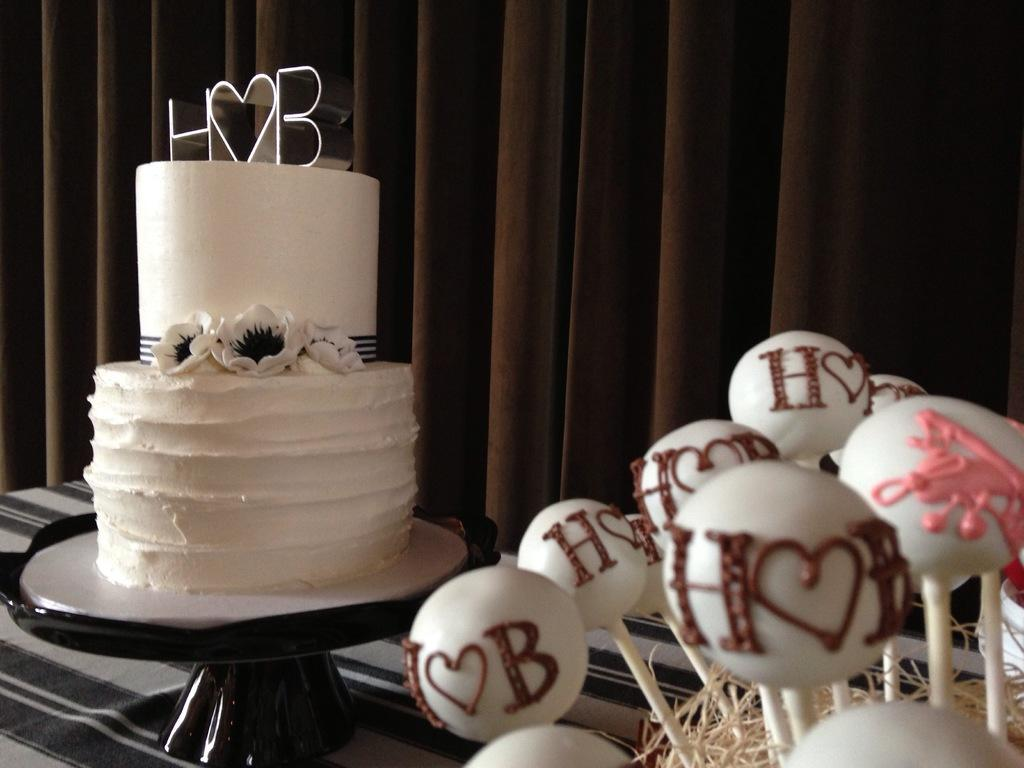What is the main subject of the image? There is a cake in the image. What is the cake placed on? The cake is placed on an object. What is the object on? The object is on a cloth. What can be seen on the right side of the image? There are food items on the right side of the image. What type of window treatment is visible in the image? There are curtains visible in the image. What type of mine is depicted in the image? There is no mine present in the image; it features a cake on a cloth with food items and curtains visible. What color is the flag in the image? There is no flag present in the image. 